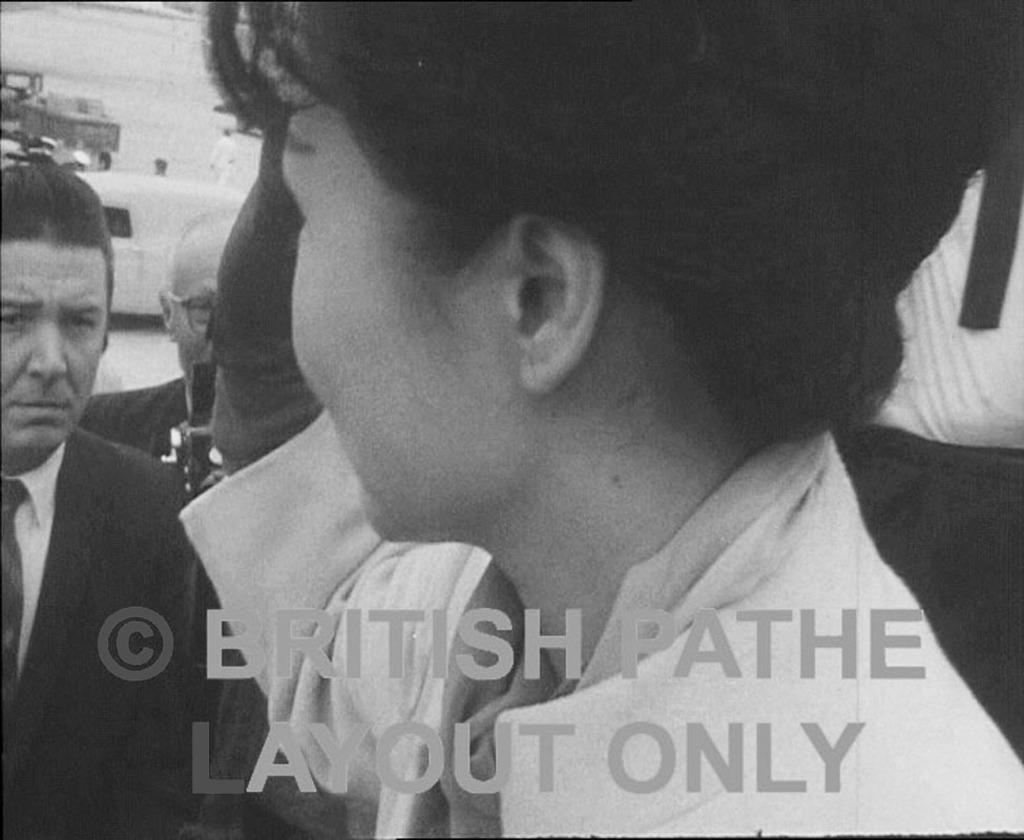Who is the main subject in the front of the image? There is a woman in the front of the image. What can be seen in the background of the image? There are persons and vehicles in the background of the image. How many cherries are hanging from the woman's hair in the image? There are no cherries present in the image, and the woman's hair does not have any hanging from it. 